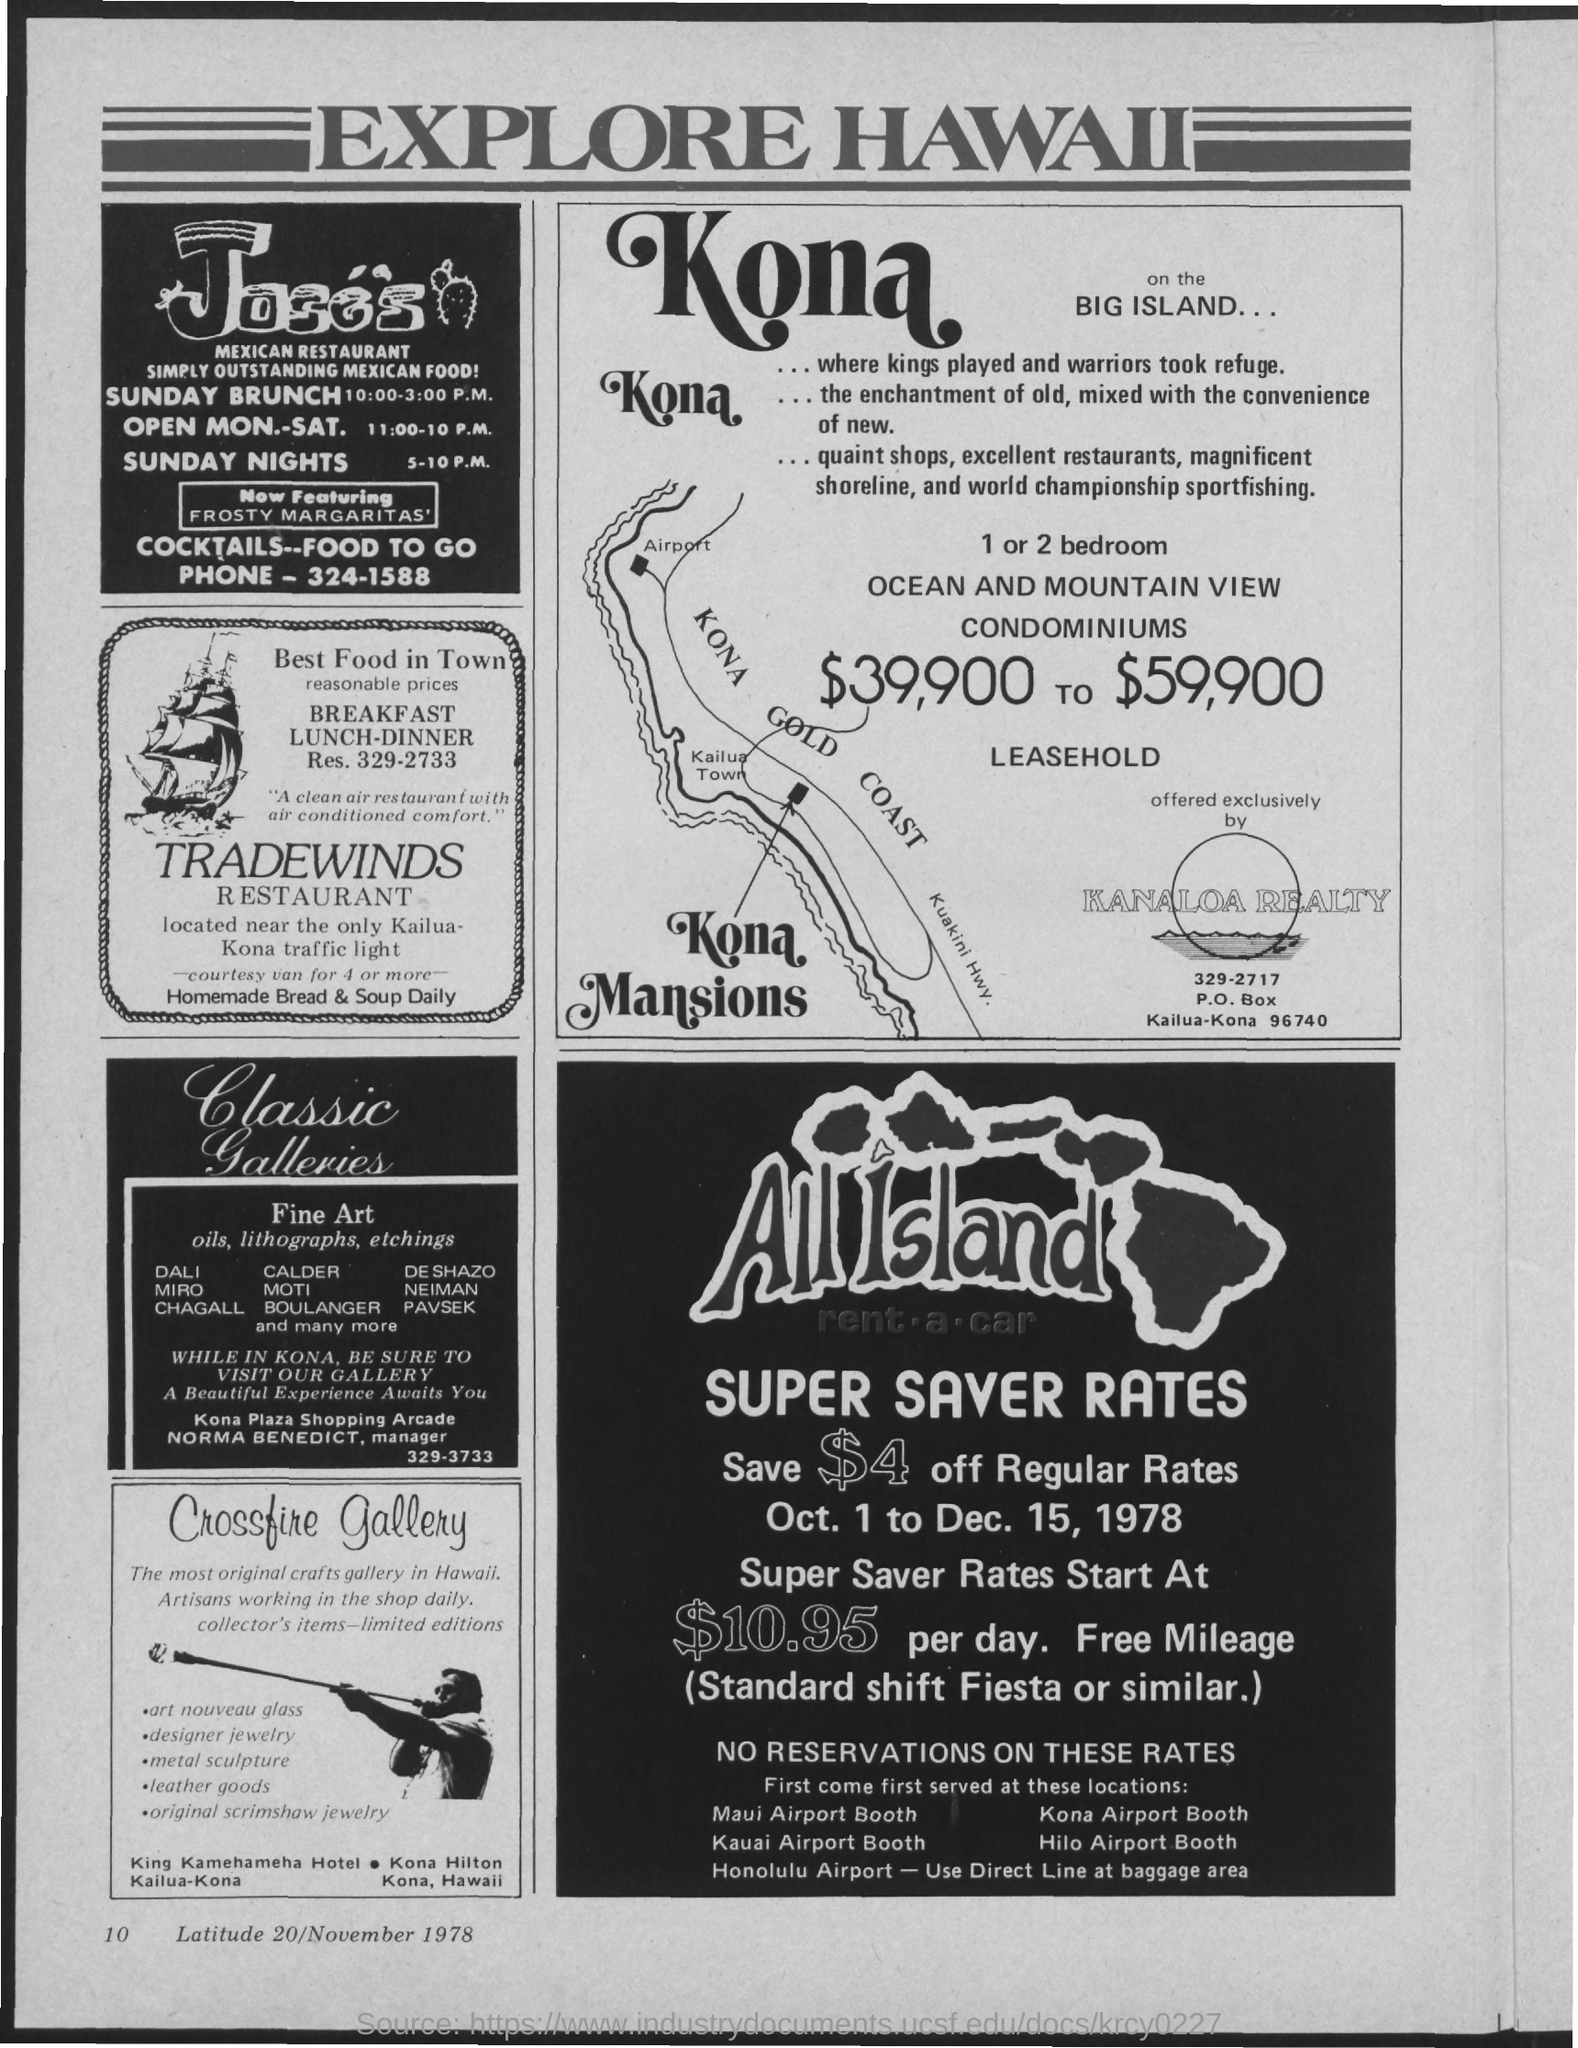What is the name of the document in which advertisements are given?
Ensure brevity in your answer.  EXPLORE HAWAII. What is the PHONE number of " Joses"?
Your answer should be compact. 324-1588. Provide the "RES." number of "TRADEWINDS RESTAURANT"?
Make the answer very short. 329-2733. Provide the "Super Saver Rates" per day of "All Island"?
Make the answer very short. $10.95. What is the page number given at left bottom corner of the page?
Ensure brevity in your answer.  10. Provide the "Latitude" number given below "Crossfire Gallery"?
Your answer should be very brief. 20. Provide the Month and Year given below "Crossfire Gallery"?
Offer a terse response. November 1978. "Super Saver Rates" for "All Island" is from which date to which date?
Offer a terse response. Oct. 1 to Dec. 15, 1978. 